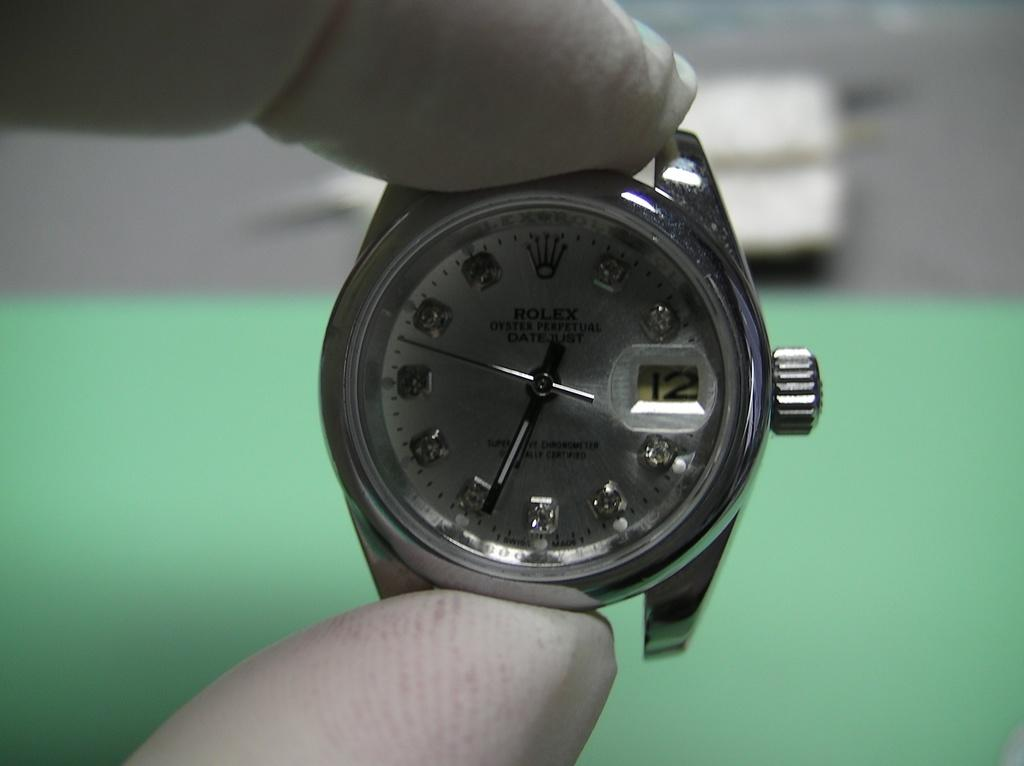What is the person holding in the image? The person's fingers are holding a bezel in the image. What is the bezel attached to? The bezel is on a watch. Can you describe the background of the image? The background of the image is blurry. Can you see any sticks on the seashore in the image? There is no seashore or sticks present in the image. 